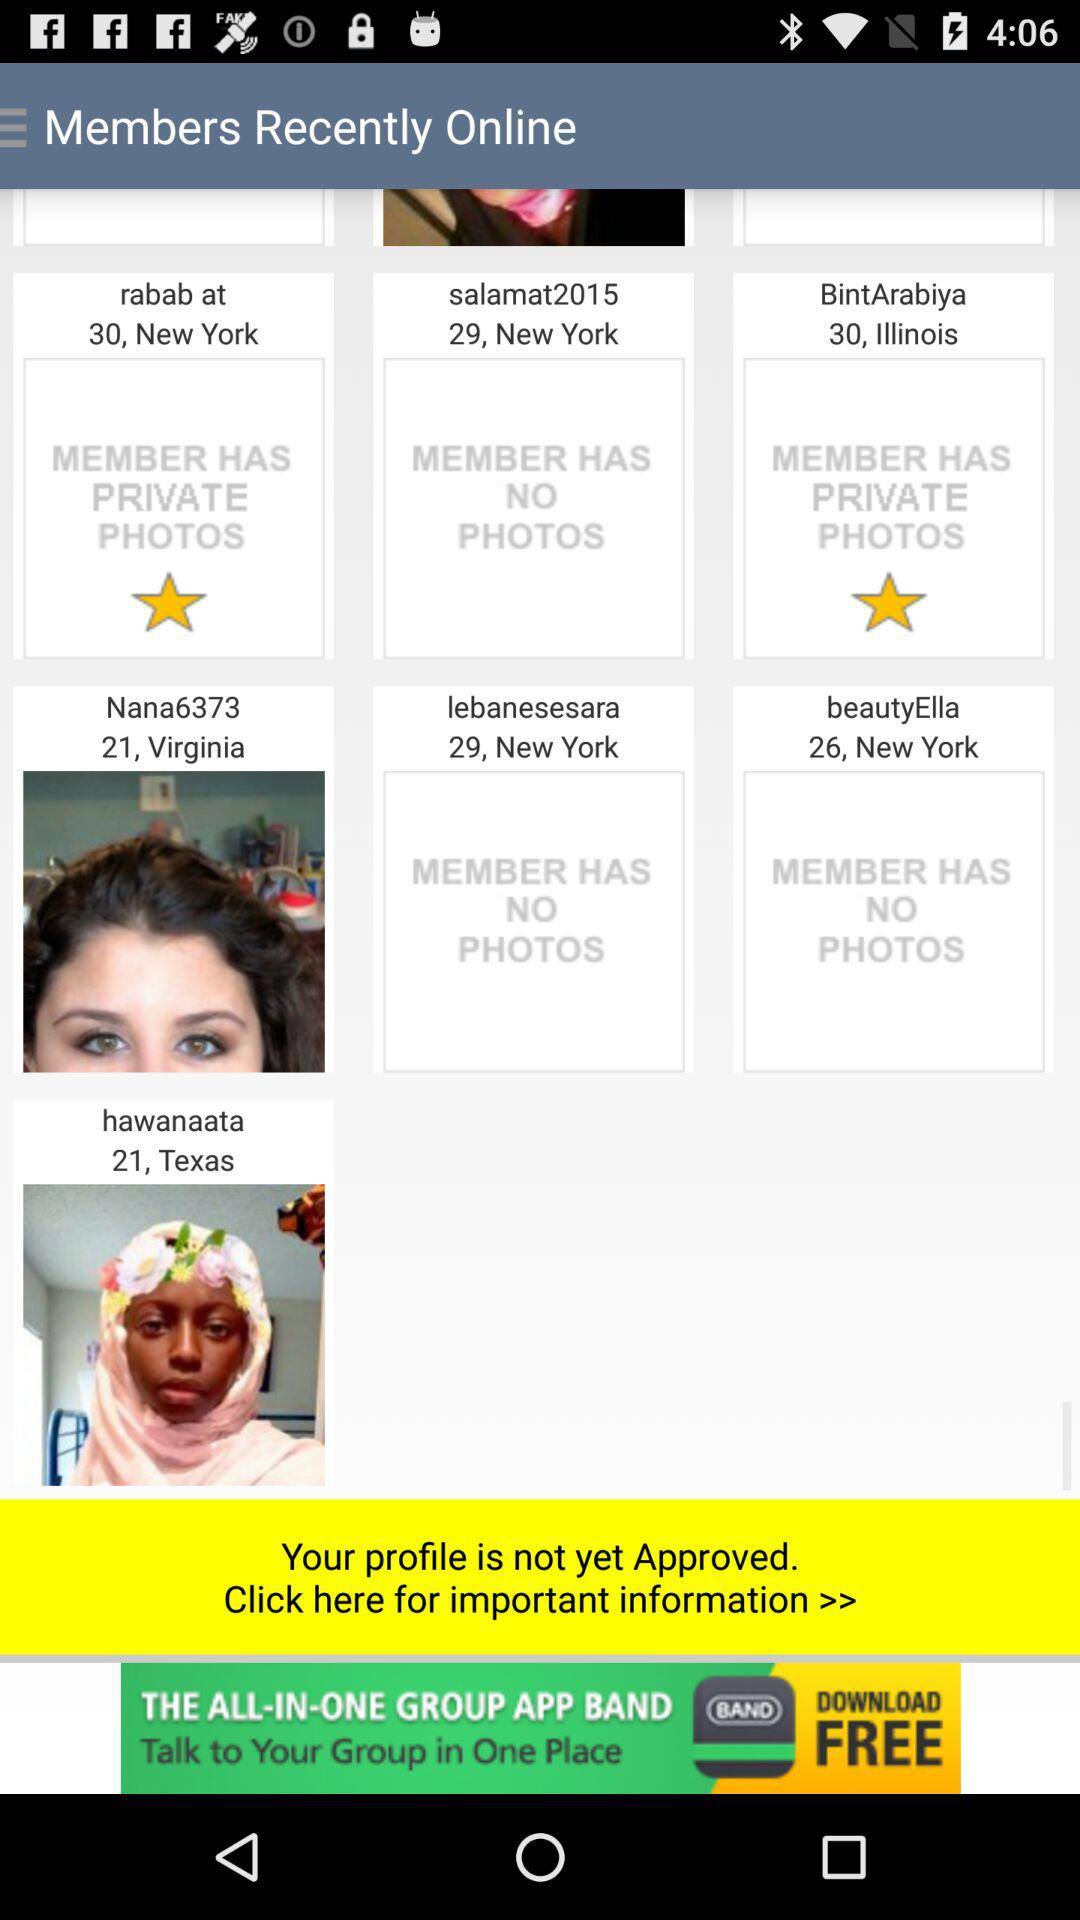How old is "beautyElla"? "beautyElla" is 26 years old. 